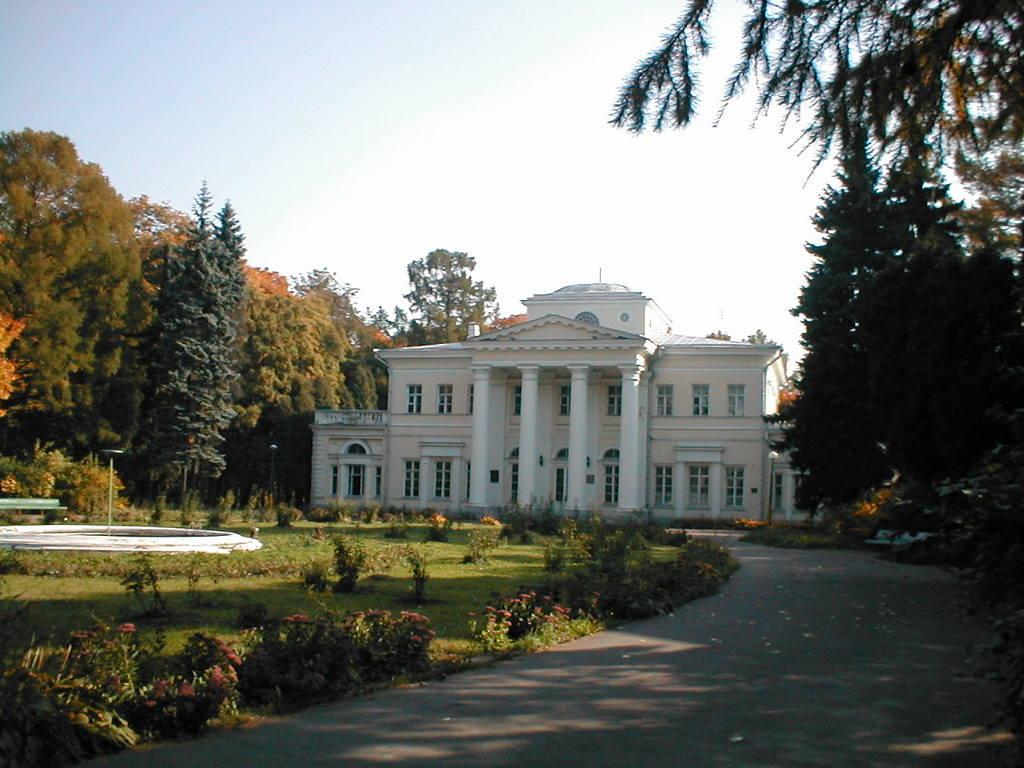What type of structure can be seen in the image? There is a building in the image. What natural elements are present in the image? There are trees, plants, and shrubs in the image. Can you describe a water feature in the image? There is a fountain in the image. What type of surface is visible in the image? The ground is visible in the image. What man-made feature can be seen in the image? There is a road in the image. What type of vertical structures are present in the image? There are poles in the image. What type of lighting is present in the image? Electric lights are present in the image. What part of the natural environment is visible in the image? The sky is visible in the image. How does the growth of the horn affect the image? There is no horn present in the image, so its growth does not affect the image. What type of attempt can be seen being made in the image? There is no attempt or action being depicted in the image; it is a static scene. 